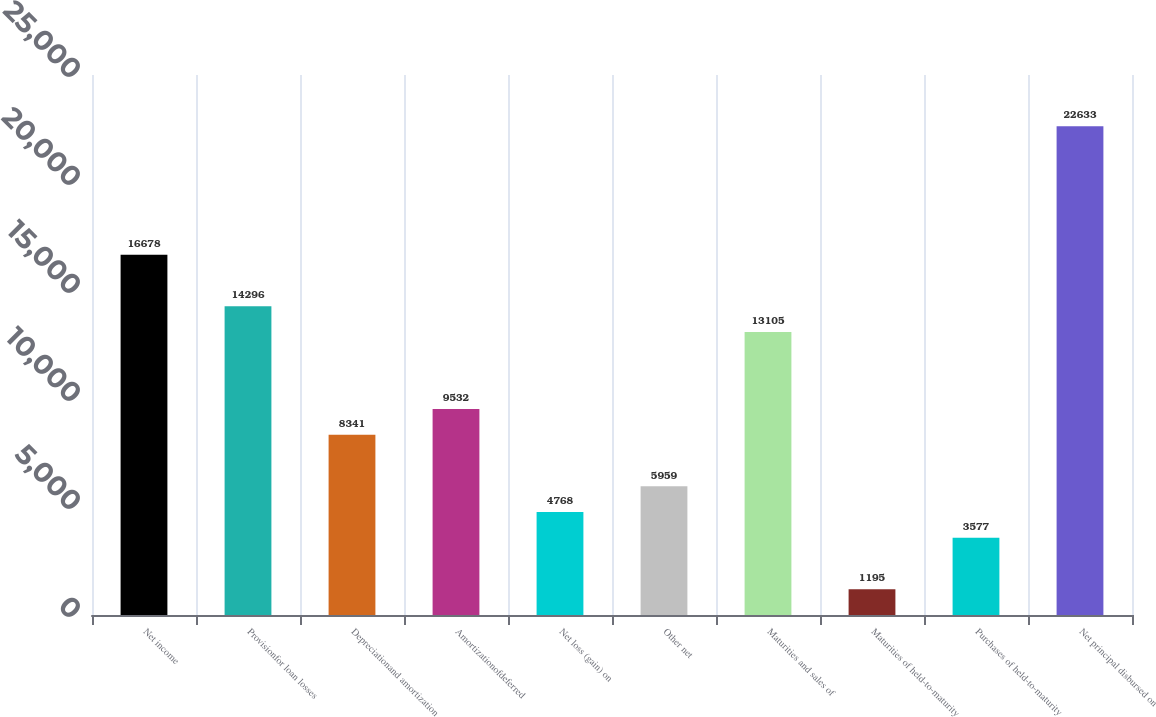Convert chart. <chart><loc_0><loc_0><loc_500><loc_500><bar_chart><fcel>Net income<fcel>Provisionfor loan losses<fcel>Depreciationand amortization<fcel>Amortizationofdeferred<fcel>Net loss (gain) on<fcel>Other net<fcel>Maturities and sales of<fcel>Maturities of held-to-maturity<fcel>Purchases of held-to-maturity<fcel>Net principal disbursed on<nl><fcel>16678<fcel>14296<fcel>8341<fcel>9532<fcel>4768<fcel>5959<fcel>13105<fcel>1195<fcel>3577<fcel>22633<nl></chart> 